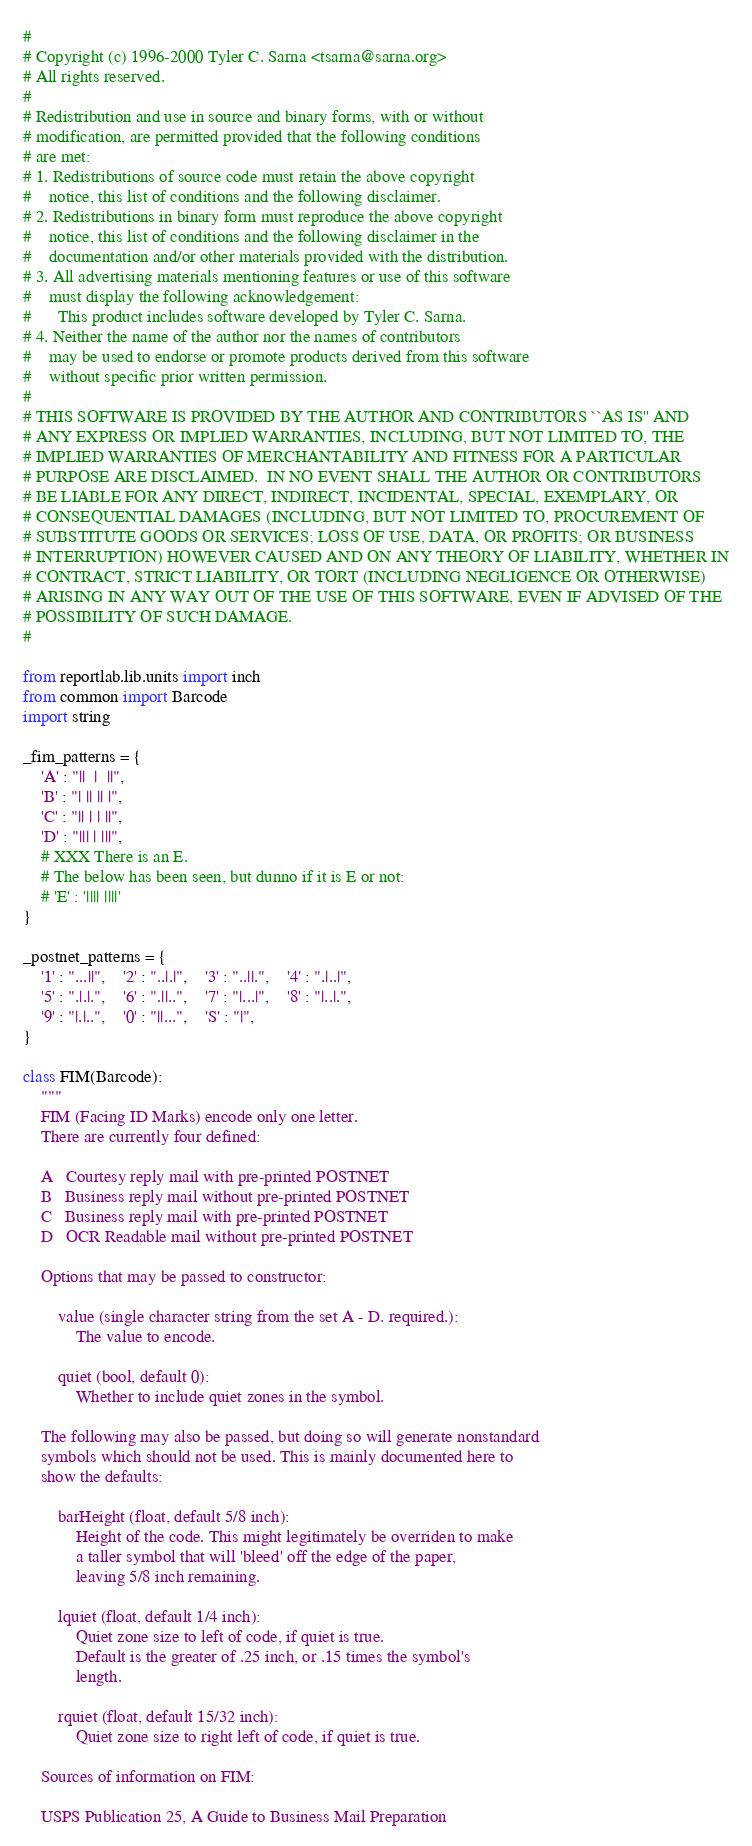<code> <loc_0><loc_0><loc_500><loc_500><_Python_>#
# Copyright (c) 1996-2000 Tyler C. Sarna <tsarna@sarna.org>
# All rights reserved.
#
# Redistribution and use in source and binary forms, with or without
# modification, are permitted provided that the following conditions
# are met:
# 1. Redistributions of source code must retain the above copyright
#    notice, this list of conditions and the following disclaimer.
# 2. Redistributions in binary form must reproduce the above copyright
#    notice, this list of conditions and the following disclaimer in the
#    documentation and/or other materials provided with the distribution.
# 3. All advertising materials mentioning features or use of this software
#    must display the following acknowledgement:
#      This product includes software developed by Tyler C. Sarna.
# 4. Neither the name of the author nor the names of contributors
#    may be used to endorse or promote products derived from this software
#    without specific prior written permission.
#
# THIS SOFTWARE IS PROVIDED BY THE AUTHOR AND CONTRIBUTORS ``AS IS'' AND
# ANY EXPRESS OR IMPLIED WARRANTIES, INCLUDING, BUT NOT LIMITED TO, THE
# IMPLIED WARRANTIES OF MERCHANTABILITY AND FITNESS FOR A PARTICULAR
# PURPOSE ARE DISCLAIMED.  IN NO EVENT SHALL THE AUTHOR OR CONTRIBUTORS
# BE LIABLE FOR ANY DIRECT, INDIRECT, INCIDENTAL, SPECIAL, EXEMPLARY, OR
# CONSEQUENTIAL DAMAGES (INCLUDING, BUT NOT LIMITED TO, PROCUREMENT OF
# SUBSTITUTE GOODS OR SERVICES; LOSS OF USE, DATA, OR PROFITS; OR BUSINESS
# INTERRUPTION) HOWEVER CAUSED AND ON ANY THEORY OF LIABILITY, WHETHER IN
# CONTRACT, STRICT LIABILITY, OR TORT (INCLUDING NEGLIGENCE OR OTHERWISE)
# ARISING IN ANY WAY OUT OF THE USE OF THIS SOFTWARE, EVEN IF ADVISED OF THE
# POSSIBILITY OF SUCH DAMAGE.
#

from reportlab.lib.units import inch
from common import Barcode
import string

_fim_patterns = {
    'A' : "||  |  ||",
    'B' : "| || || |",
    'C' : "|| | | ||",
    'D' : "||| | |||",
    # XXX There is an E.
    # The below has been seen, but dunno if it is E or not:
    # 'E' : '|||| ||||'
}

_postnet_patterns = {
    '1' : "...||",    '2' : "..|.|",    '3' : "..||.",    '4' : ".|..|",
    '5' : ".|.|.",    '6' : ".||..",    '7' : "|...|",    '8' : "|..|.",
    '9' : "|.|..",    '0' : "||...",    'S' : "|",
}

class FIM(Barcode):
    """
    FIM (Facing ID Marks) encode only one letter.
    There are currently four defined:

    A   Courtesy reply mail with pre-printed POSTNET
    B   Business reply mail without pre-printed POSTNET
    C   Business reply mail with pre-printed POSTNET
    D   OCR Readable mail without pre-printed POSTNET

    Options that may be passed to constructor:

        value (single character string from the set A - D. required.):
            The value to encode.

        quiet (bool, default 0):
            Whether to include quiet zones in the symbol.

    The following may also be passed, but doing so will generate nonstandard
    symbols which should not be used. This is mainly documented here to
    show the defaults:

        barHeight (float, default 5/8 inch):
            Height of the code. This might legitimately be overriden to make
            a taller symbol that will 'bleed' off the edge of the paper,
            leaving 5/8 inch remaining.

        lquiet (float, default 1/4 inch):
            Quiet zone size to left of code, if quiet is true.
            Default is the greater of .25 inch, or .15 times the symbol's
            length.

        rquiet (float, default 15/32 inch):
            Quiet zone size to right left of code, if quiet is true.

    Sources of information on FIM:

    USPS Publication 25, A Guide to Business Mail Preparation</code> 